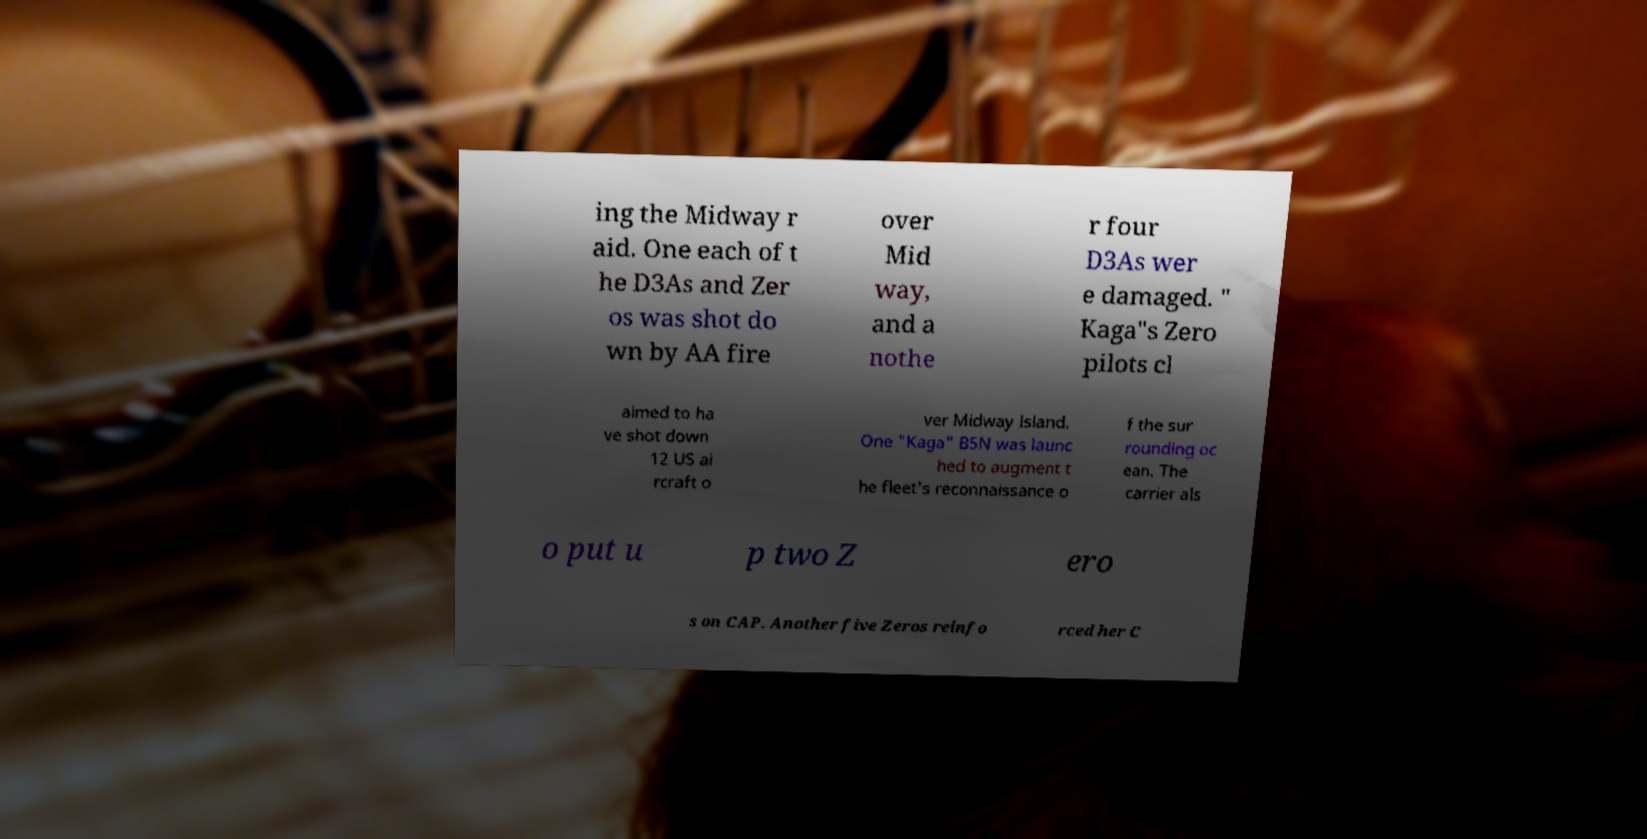Could you extract and type out the text from this image? ing the Midway r aid. One each of t he D3As and Zer os was shot do wn by AA fire over Mid way, and a nothe r four D3As wer e damaged. " Kaga"s Zero pilots cl aimed to ha ve shot down 12 US ai rcraft o ver Midway Island. One "Kaga" B5N was launc hed to augment t he fleet's reconnaissance o f the sur rounding oc ean. The carrier als o put u p two Z ero s on CAP. Another five Zeros reinfo rced her C 